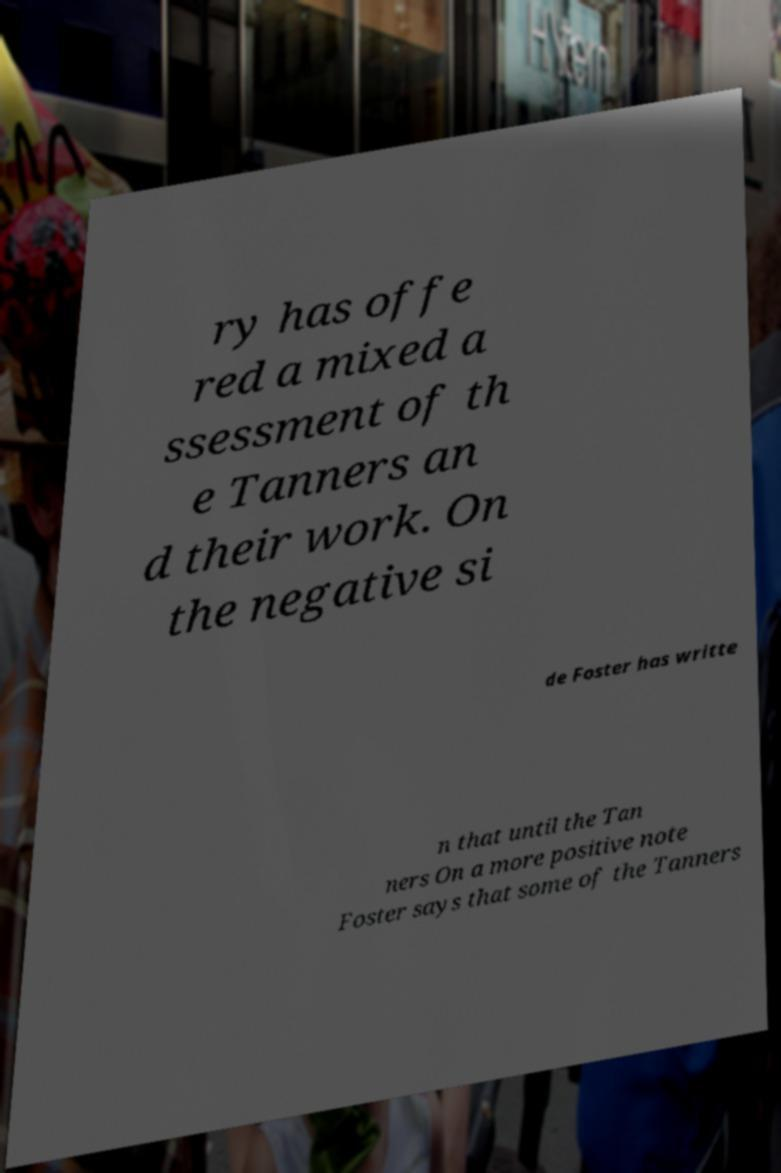There's text embedded in this image that I need extracted. Can you transcribe it verbatim? ry has offe red a mixed a ssessment of th e Tanners an d their work. On the negative si de Foster has writte n that until the Tan ners On a more positive note Foster says that some of the Tanners 